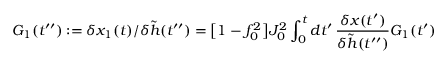Convert formula to latex. <formula><loc_0><loc_0><loc_500><loc_500>G _ { 1 } ( t ^ { \prime \prime } ) \colon = \delta x _ { 1 } ( t ) / \delta \tilde { h } ( t ^ { \prime \prime } ) = \left [ 1 - f _ { 0 } ^ { 2 } \right ] J _ { 0 } ^ { 2 } \int _ { 0 } ^ { t } d t ^ { \prime } \, \frac { \delta x ( t ^ { \prime } ) } { \delta \tilde { h } ( t ^ { \prime \prime } ) } G _ { 1 } ( t ^ { \prime } )</formula> 